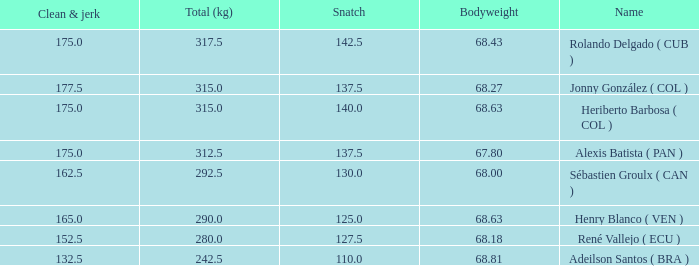Tell me the highest snatch for 68.63 bodyweight and total kg less than 290 None. 